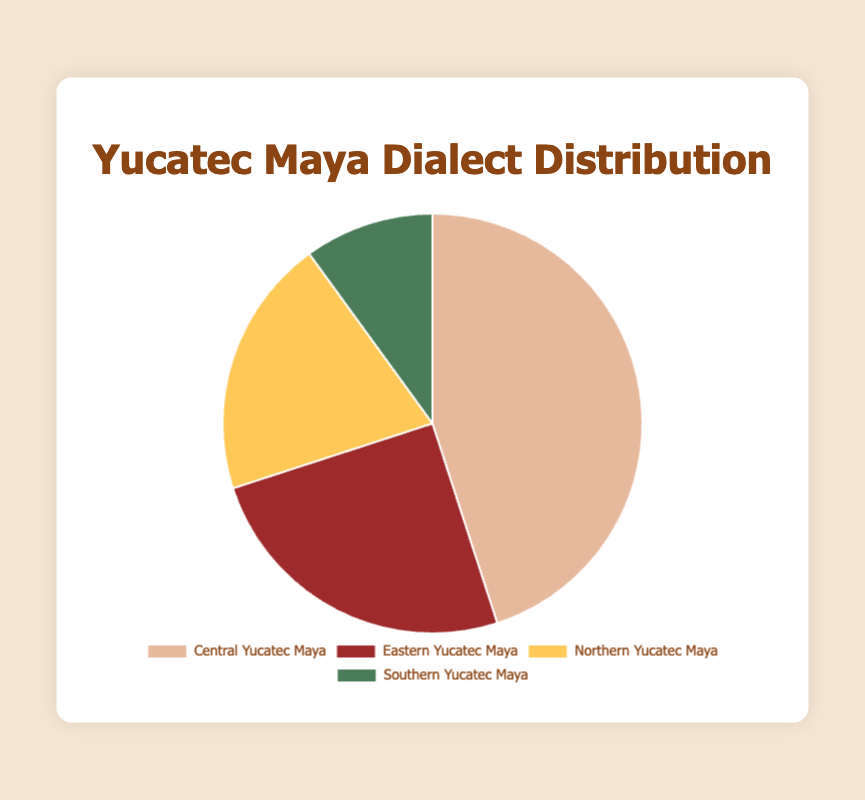What is the proportion of the least spoken dialect? The least spoken dialect in the chart is Southern Yucatec Maya, represented by the smallest segment. The chart shows a 10% proportion for this dialect.
Answer: 10% Which dialects together make up more than half of the community? Central Yucatec Maya has a 45% proportion, and Eastern Yucatec Maya has a 25% proportion. Summing these up, 45% + 25% = 70%, which is more than half of the total.
Answer: Central Yucatec Maya and Eastern Yucatec Maya What is the difference in the proportion between Central Yucatec Maya and Northern Yucatec Maya? Central Yucatec Maya has a 45% proportion, while Northern Yucatec Maya has a 20% proportion. The difference is calculated as 45% - 20% = 25%.
Answer: 25% Which dialect has exactly double the proportion of Southern Yucatec Maya? Southern Yucatec Maya has a 10% proportion. The dialect with double this proportion is Northern Yucatec Maya, which has a 20% proportion.
Answer: Northern Yucatec Maya What is the average proportion of all four dialects? The total proportion is 45% + 25% + 20% + 10% = 100%. Since there are four dialects, the average is 100% / 4 = 25%.
Answer: 25% Which two dialects together have the same combined proportion as Central Yucatec Maya? Central Yucatec Maya has a 45% proportion. Eastern Yucatec Maya and Northern Yucatec Maya together have 25% + 20% = 45%, matching the proportion of Central Yucatec Maya.
Answer: Eastern Yucatec Maya and Northern Yucatec Maya Which color represents the Eastern Yucatec Maya dialect in the chart? The Eastern Yucatec Maya dialect is represented by the red segment in the pie chart.
Answer: Red 